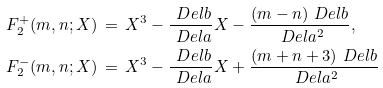<formula> <loc_0><loc_0><loc_500><loc_500>F _ { 2 } ^ { + } ( m , n ; X ) \, & = \, X ^ { 3 } - \frac { \ D e l b } { \ D e l a } X - \frac { ( m - n ) \ D e l b } { \ D e l a ^ { 2 } } , \\ F _ { 2 } ^ { - } ( m , n ; X ) \, & = \, X ^ { 3 } - \frac { \ D e l b } { \ D e l a } X + \frac { ( m + n + 3 ) \ D e l b } { \ D e l a ^ { 2 } }</formula> 